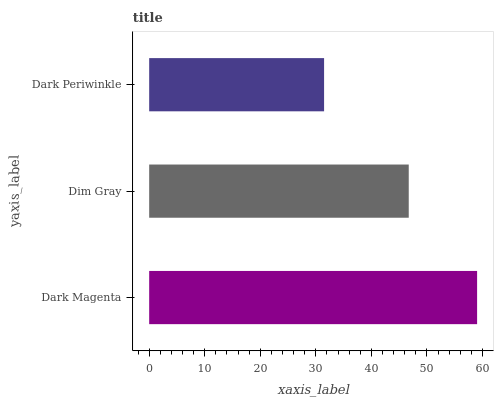Is Dark Periwinkle the minimum?
Answer yes or no. Yes. Is Dark Magenta the maximum?
Answer yes or no. Yes. Is Dim Gray the minimum?
Answer yes or no. No. Is Dim Gray the maximum?
Answer yes or no. No. Is Dark Magenta greater than Dim Gray?
Answer yes or no. Yes. Is Dim Gray less than Dark Magenta?
Answer yes or no. Yes. Is Dim Gray greater than Dark Magenta?
Answer yes or no. No. Is Dark Magenta less than Dim Gray?
Answer yes or no. No. Is Dim Gray the high median?
Answer yes or no. Yes. Is Dim Gray the low median?
Answer yes or no. Yes. Is Dark Periwinkle the high median?
Answer yes or no. No. Is Dark Magenta the low median?
Answer yes or no. No. 